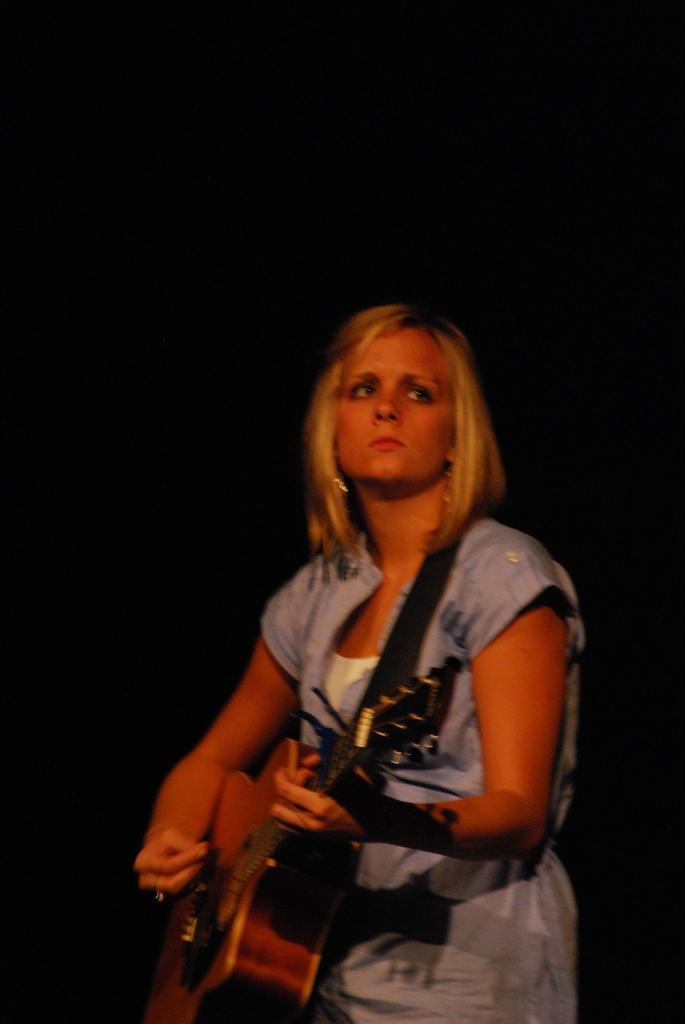Describe this image in one or two sentences. In the middle of the image a woman is standing and playing guitar. 